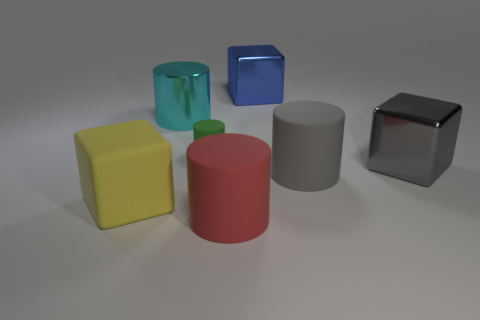How many other things are the same color as the large metal cylinder?
Your response must be concise. 0. What number of tiny green cylinders are made of the same material as the large red thing?
Give a very brief answer. 1. How many red objects are either large cylinders or big rubber cubes?
Offer a very short reply. 1. Is the material of the large gray thing that is in front of the gray cube the same as the green cylinder?
Give a very brief answer. Yes. What number of objects are either large red things or objects behind the large gray metallic thing?
Provide a short and direct response. 4. There is a big cube that is to the right of the large matte object that is to the right of the large blue metal block; how many big cyan objects are to the right of it?
Ensure brevity in your answer.  0. Do the shiny thing to the right of the big blue object and the big blue object have the same shape?
Make the answer very short. Yes. There is a large thing in front of the rubber block; is there a green rubber object that is to the right of it?
Make the answer very short. No. What number of big things are there?
Provide a short and direct response. 6. The big cylinder that is behind the red matte object and on the right side of the cyan thing is what color?
Give a very brief answer. Gray. 